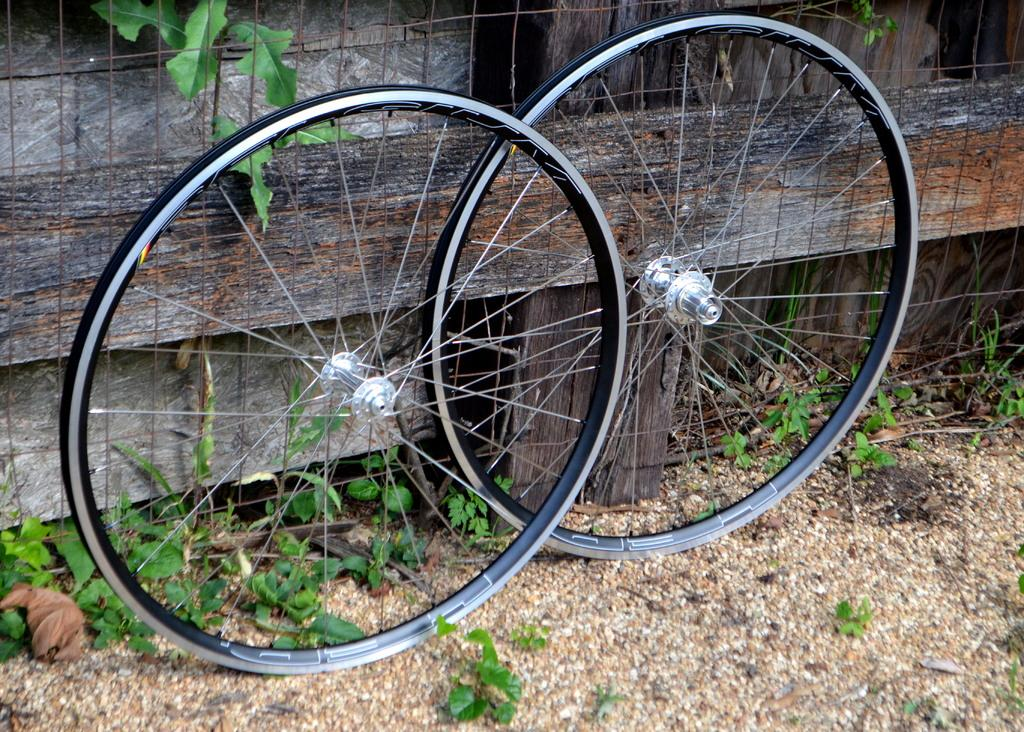What objects are present in the image? There are two tires in the image. Where are the tires located in relation to other objects? The tires are in front of a wooden fence. What type of ground is visible in the image? The ground is sandy. What is the price of the love disease in the image? There is no mention of love, disease, or price in the image; it only features two tires in front of a wooden fence on sandy ground. 